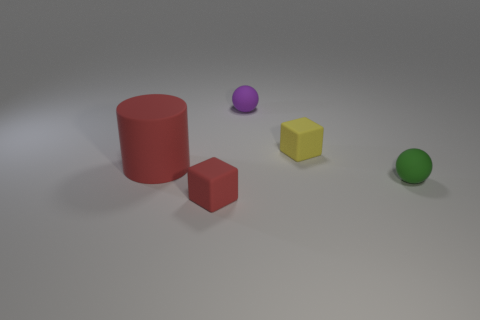Is there anything else that has the same size as the matte cylinder?
Your answer should be very brief. No. Are there any other green objects that have the same shape as the small green rubber thing?
Your answer should be compact. No. Are there the same number of purple things in front of the tiny red block and small green matte things that are in front of the small green object?
Offer a very short reply. Yes. There is a object that is to the right of the small yellow matte thing; does it have the same shape as the small purple matte thing?
Your answer should be very brief. Yes. Is the shape of the small green matte object the same as the purple object?
Your answer should be very brief. Yes. What number of metal things are yellow things or tiny red cubes?
Your answer should be very brief. 0. Is the purple thing the same size as the cylinder?
Ensure brevity in your answer.  No. How many objects are large rubber cylinders or cubes right of the purple rubber object?
Make the answer very short. 2. What is the material of the yellow object that is the same size as the green rubber sphere?
Your response must be concise. Rubber. There is a rubber ball in front of the small yellow matte thing; are there any large objects in front of it?
Your answer should be compact. No. 